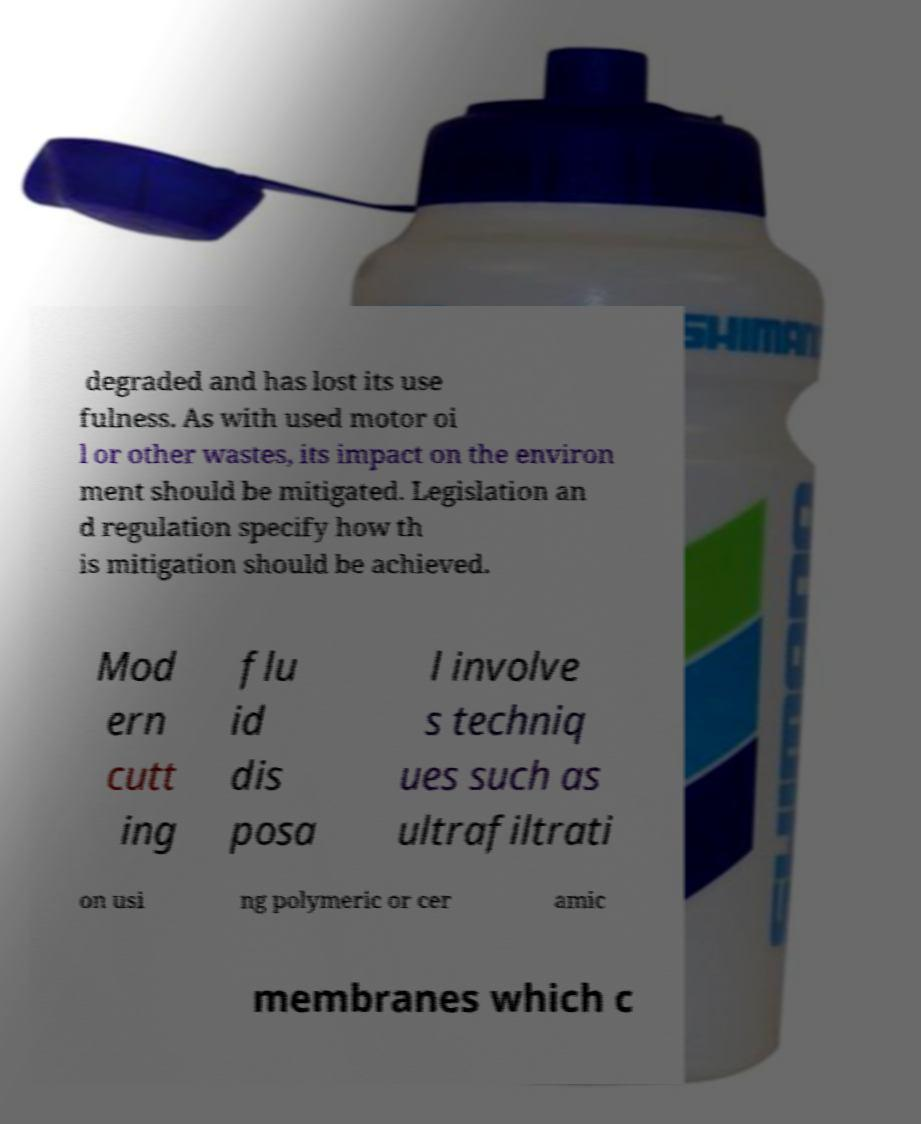Please identify and transcribe the text found in this image. degraded and has lost its use fulness. As with used motor oi l or other wastes, its impact on the environ ment should be mitigated. Legislation an d regulation specify how th is mitigation should be achieved. Mod ern cutt ing flu id dis posa l involve s techniq ues such as ultrafiltrati on usi ng polymeric or cer amic membranes which c 